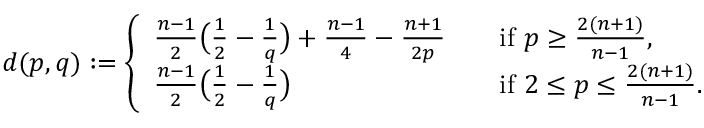<formula> <loc_0><loc_0><loc_500><loc_500>d ( p , q ) \colon = \left \{ \begin{array} { l l } { \frac { n - 1 } { 2 } \left ( \frac { 1 } { 2 } - \frac { 1 } { q } \right ) + \frac { n - 1 } { 4 } - \frac { n + 1 } { 2 p } } & { \quad i f p \geq \frac { 2 ( n + 1 ) } { n - 1 } , } \\ { \frac { n - 1 } { 2 } \left ( \frac { 1 } { 2 } - \frac { 1 } { q } \right ) } & { \quad i f 2 \leq p \leq \frac { 2 ( n + 1 ) } { n - 1 } . } \end{array}</formula> 